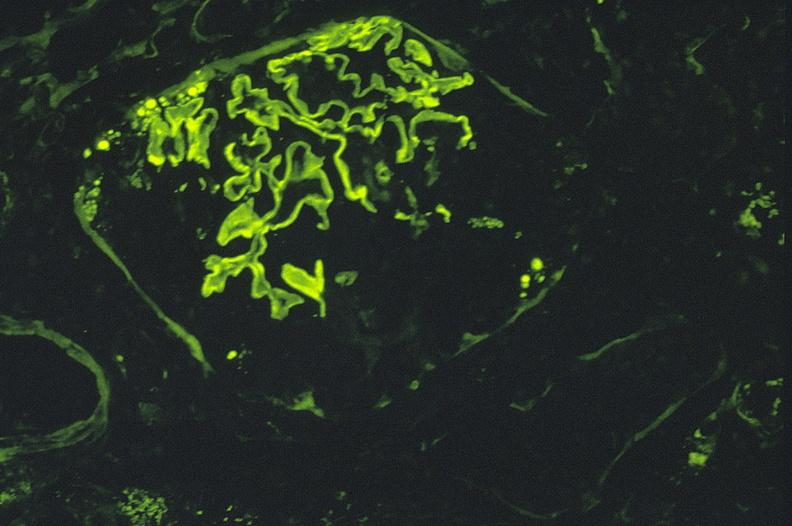where is this?
Answer the question using a single word or phrase. Urinary 